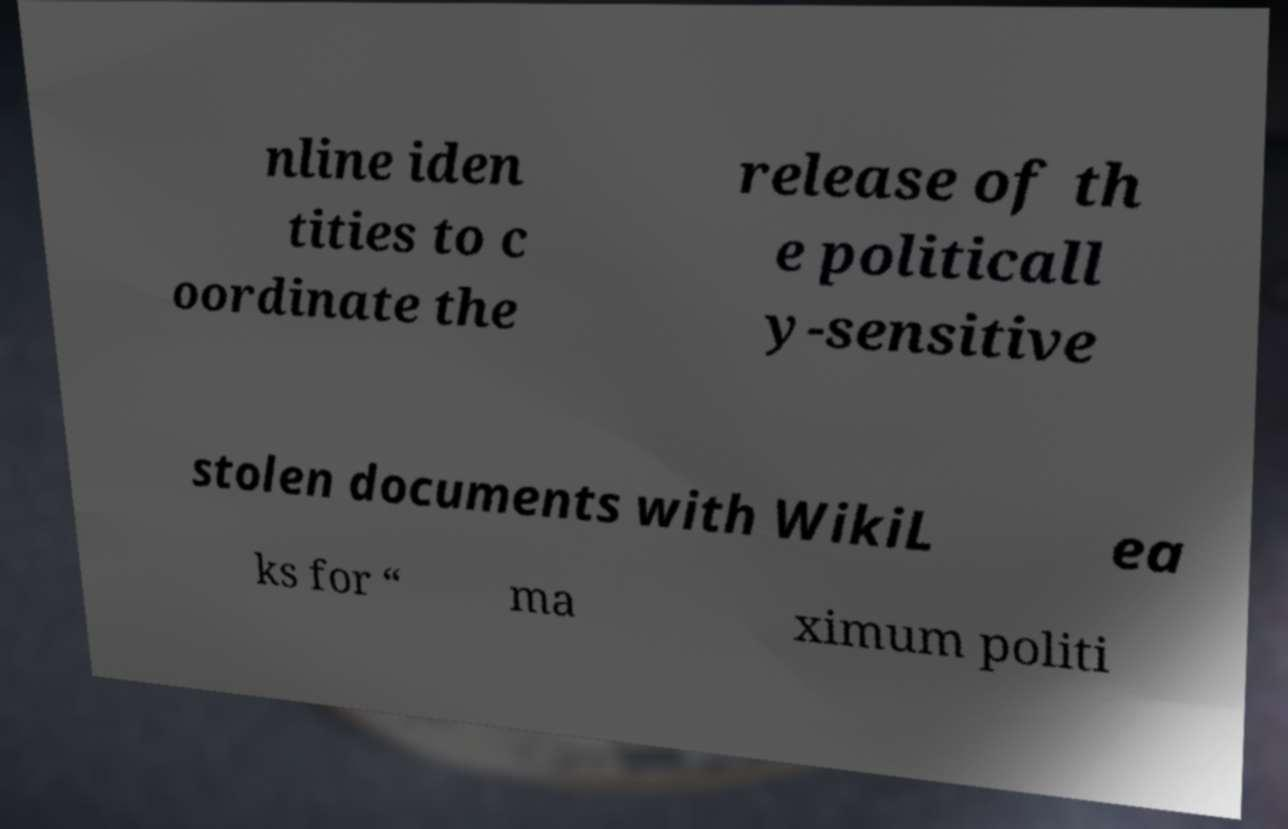Could you extract and type out the text from this image? nline iden tities to c oordinate the release of th e politicall y-sensitive stolen documents with WikiL ea ks for “ ma ximum politi 